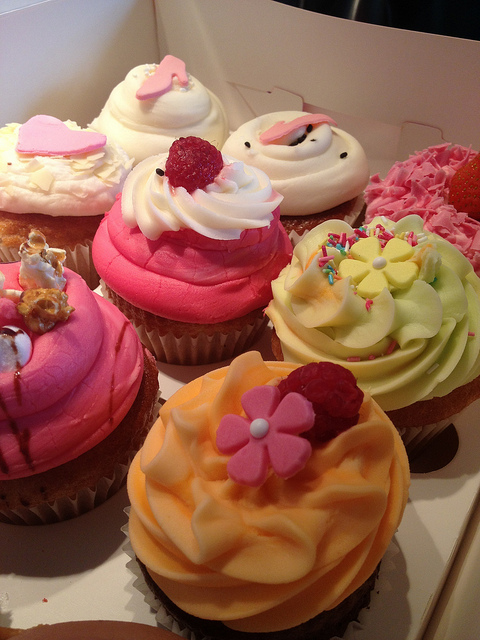What flavors might these cupcakes be based on their colors? The cupcakes' colors suggest a range of flavors: the pink one could be strawberry or raspberry, the yellow might hint at a lemon tang, and the green could be mint or pistachio. The white cupcake often signifies a classic vanilla flavor, and the ones with fruit toppings might incorporate those fruits into their flavor profile as well. 